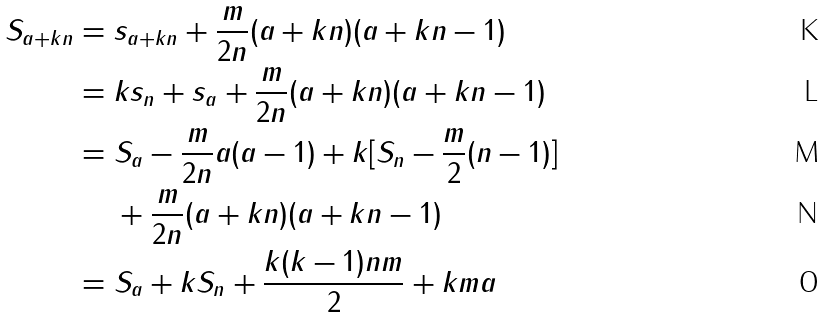Convert formula to latex. <formula><loc_0><loc_0><loc_500><loc_500>S _ { a + k n } & = s _ { a + k n } + \frac { m } { 2 n } ( a + k n ) ( a + k n - 1 ) \\ & = k s _ { n } + s _ { a } + \frac { m } { 2 n } ( a + k n ) ( a + k n - 1 ) \\ & = S _ { a } - \frac { m } { 2 n } a ( a - 1 ) + k [ S _ { n } - \frac { m } { 2 } ( n - 1 ) ] \\ & \quad \ + \frac { m } { 2 n } ( a + k n ) ( a + k n - 1 ) \\ & = S _ { a } + k S _ { n } + \frac { k ( k - 1 ) n m } { 2 } + k m a</formula> 